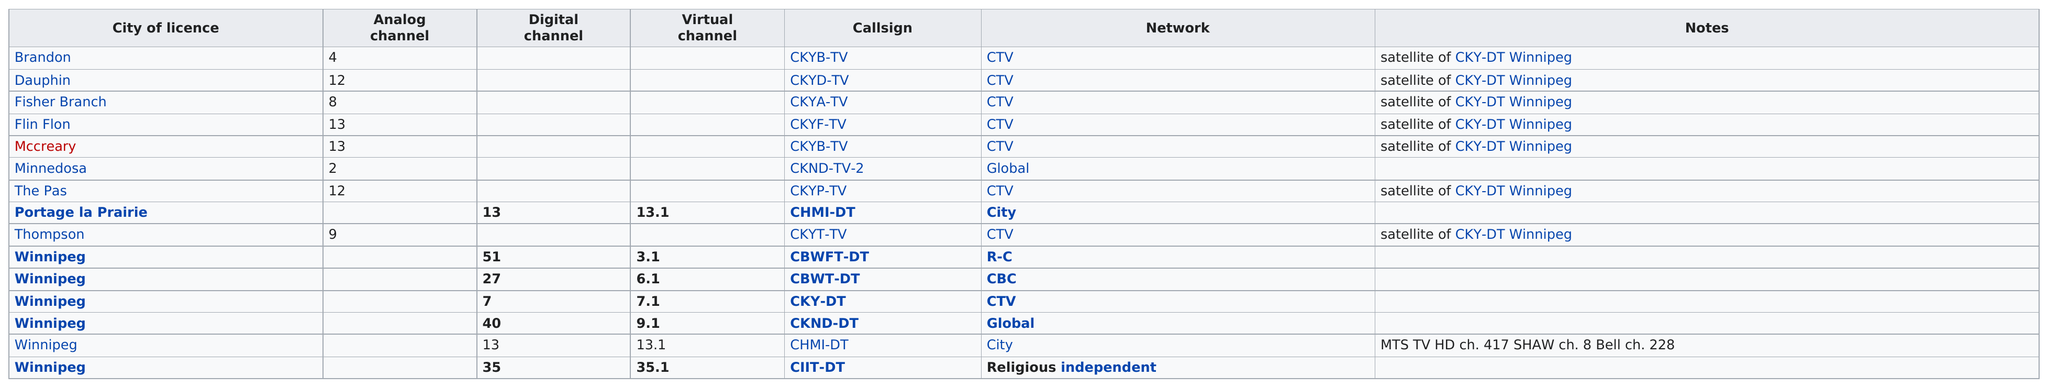List a handful of essential elements in this visual. CTV has the most satellite stations among all networks. Eight analog stations are included in the list. CBWT-DT, a CBC station, has both a digital and a virtual channel. 